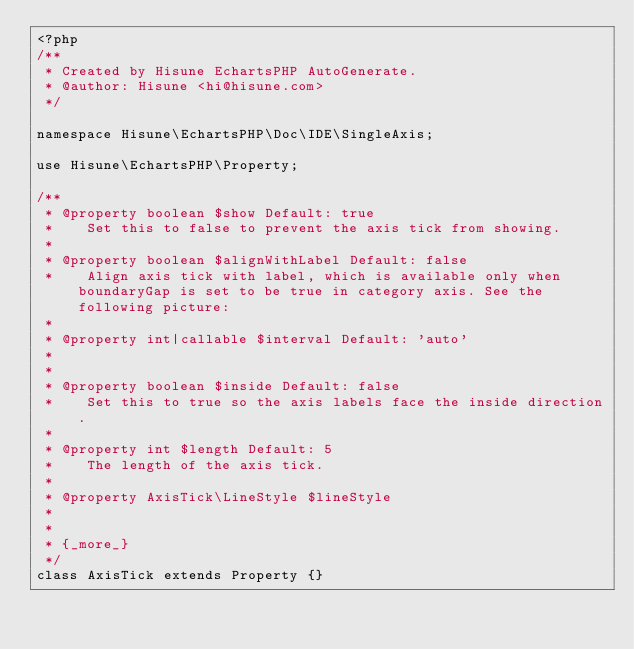Convert code to text. <code><loc_0><loc_0><loc_500><loc_500><_PHP_><?php
/**
 * Created by Hisune EchartsPHP AutoGenerate.
 * @author: Hisune <hi@hisune.com>
 */

namespace Hisune\EchartsPHP\Doc\IDE\SingleAxis;

use Hisune\EchartsPHP\Property;

/**
 * @property boolean $show Default: true
 *    Set this to false to prevent the axis tick from showing.
 *
 * @property boolean $alignWithLabel Default: false
 *    Align axis tick with label, which is available only when boundaryGap is set to be true in category axis. See the following picture:
 *
 * @property int|callable $interval Default: 'auto'
 *    
 *
 * @property boolean $inside Default: false
 *    Set this to true so the axis labels face the inside direction.
 *
 * @property int $length Default: 5
 *    The length of the axis tick.
 *
 * @property AxisTick\LineStyle $lineStyle
 *    
 *
 * {_more_}
 */
class AxisTick extends Property {}</code> 